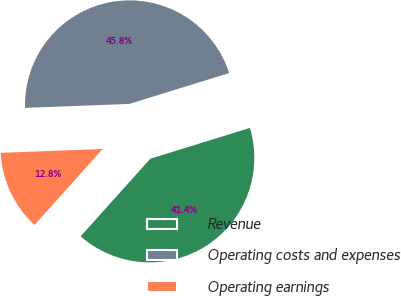<chart> <loc_0><loc_0><loc_500><loc_500><pie_chart><fcel>Revenue<fcel>Operating costs and expenses<fcel>Operating earnings<nl><fcel>41.42%<fcel>45.83%<fcel>12.75%<nl></chart> 